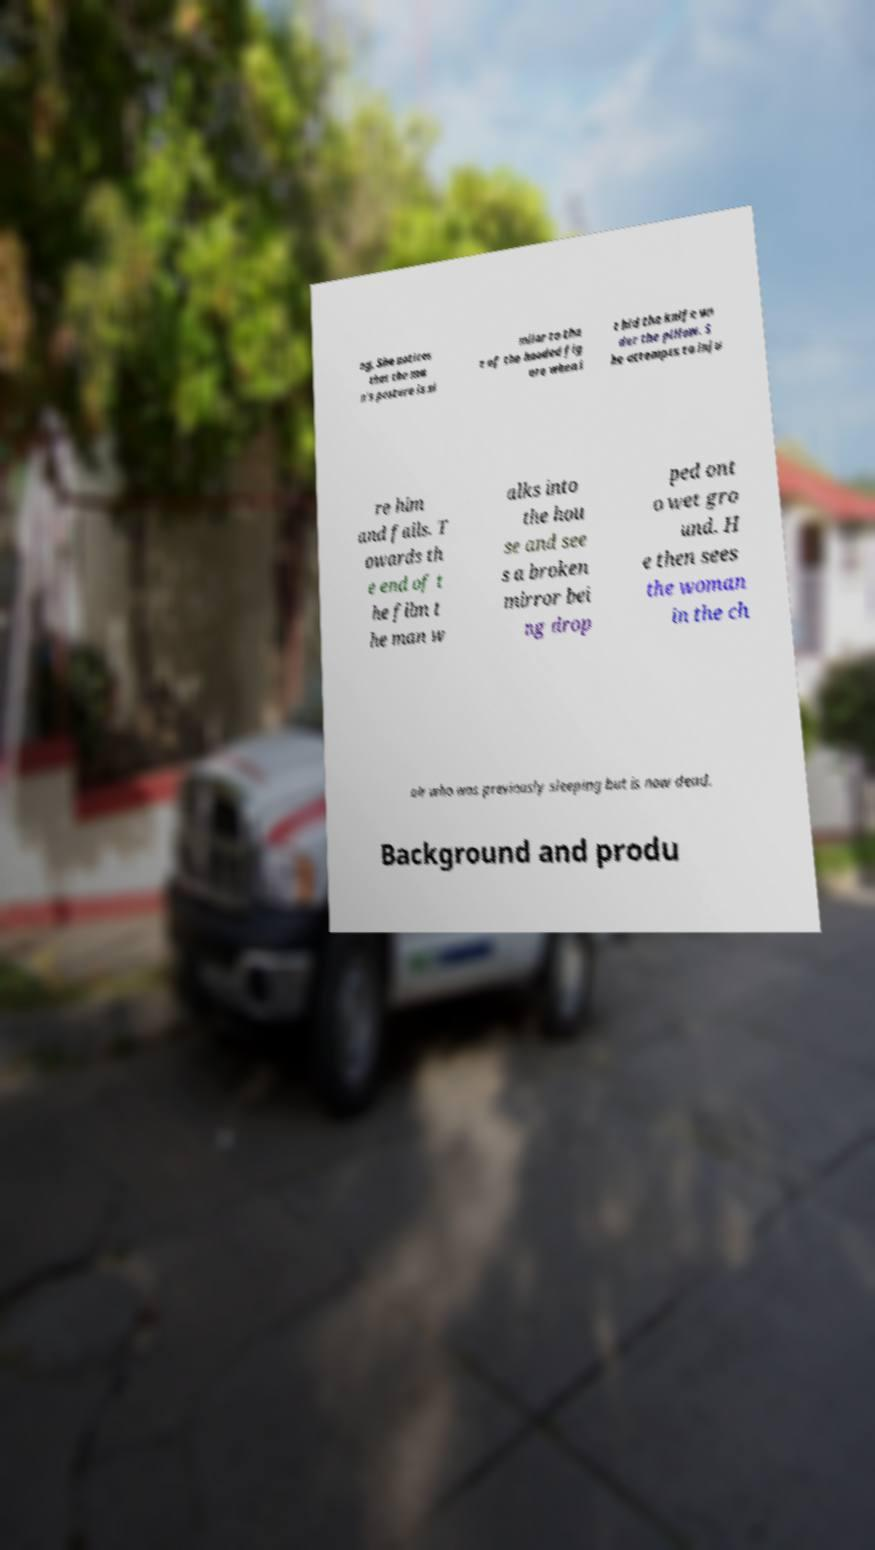Please read and relay the text visible in this image. What does it say? ng. She notices that the ma n's posture is si milar to tha t of the hooded fig ure when i t hid the knife un der the pillow. S he attempts to inju re him and fails. T owards th e end of t he film t he man w alks into the hou se and see s a broken mirror bei ng drop ped ont o wet gro und. H e then sees the woman in the ch air who was previously sleeping but is now dead. Background and produ 